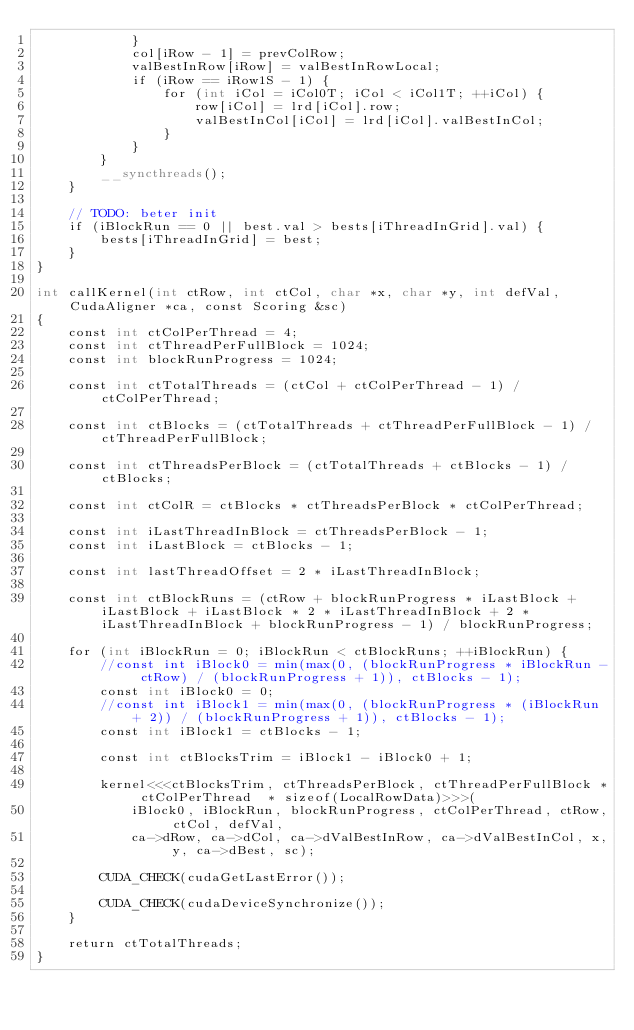Convert code to text. <code><loc_0><loc_0><loc_500><loc_500><_Cuda_>            }
            col[iRow - 1] = prevColRow;
            valBestInRow[iRow] = valBestInRowLocal;
            if (iRow == iRow1S - 1) {
                for (int iCol = iCol0T; iCol < iCol1T; ++iCol) {
                    row[iCol] = lrd[iCol].row;
                    valBestInCol[iCol] = lrd[iCol].valBestInCol;
                }
            }
        }
        __syncthreads();
    }

    // TODO: beter init
    if (iBlockRun == 0 || best.val > bests[iThreadInGrid].val) {
        bests[iThreadInGrid] = best;
    }
} 

int callKernel(int ctRow, int ctCol, char *x, char *y, int defVal, CudaAligner *ca, const Scoring &sc)
{
    const int ctColPerThread = 4;
    const int ctThreadPerFullBlock = 1024;
    const int blockRunProgress = 1024;

    const int ctTotalThreads = (ctCol + ctColPerThread - 1) / ctColPerThread;

    const int ctBlocks = (ctTotalThreads + ctThreadPerFullBlock - 1) / ctThreadPerFullBlock;

    const int ctThreadsPerBlock = (ctTotalThreads + ctBlocks - 1) / ctBlocks;

    const int ctColR = ctBlocks * ctThreadsPerBlock * ctColPerThread;

    const int iLastThreadInBlock = ctThreadsPerBlock - 1;
    const int iLastBlock = ctBlocks - 1;

    const int lastThreadOffset = 2 * iLastThreadInBlock;

    const int ctBlockRuns = (ctRow + blockRunProgress * iLastBlock + iLastBlock + iLastBlock * 2 * iLastThreadInBlock + 2 * iLastThreadInBlock + blockRunProgress - 1) / blockRunProgress;

    for (int iBlockRun = 0; iBlockRun < ctBlockRuns; ++iBlockRun) {
        //const int iBlock0 = min(max(0, (blockRunProgress * iBlockRun - ctRow) / (blockRunProgress + 1)), ctBlocks - 1);
        const int iBlock0 = 0;
        //const int iBlock1 = min(max(0, (blockRunProgress * (iBlockRun + 2)) / (blockRunProgress + 1)), ctBlocks - 1);
        const int iBlock1 = ctBlocks - 1;

        const int ctBlocksTrim = iBlock1 - iBlock0 + 1;

        kernel<<<ctBlocksTrim, ctThreadsPerBlock, ctThreadPerFullBlock * ctColPerThread  * sizeof(LocalRowData)>>>(
            iBlock0, iBlockRun, blockRunProgress, ctColPerThread, ctRow, ctCol, defVal,
            ca->dRow, ca->dCol, ca->dValBestInRow, ca->dValBestInCol, x, y, ca->dBest, sc);

        CUDA_CHECK(cudaGetLastError());

        CUDA_CHECK(cudaDeviceSynchronize());
    }

    return ctTotalThreads;
}
</code> 